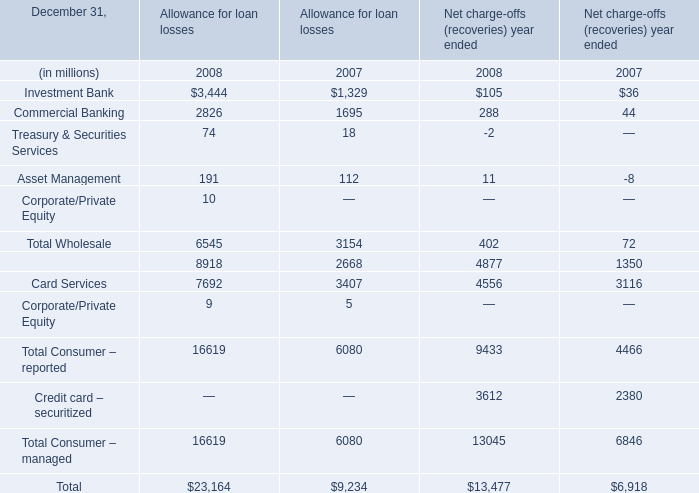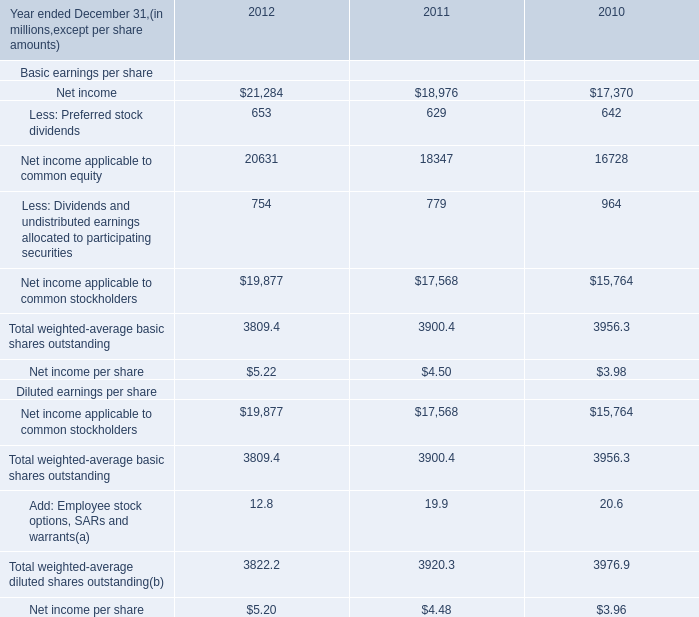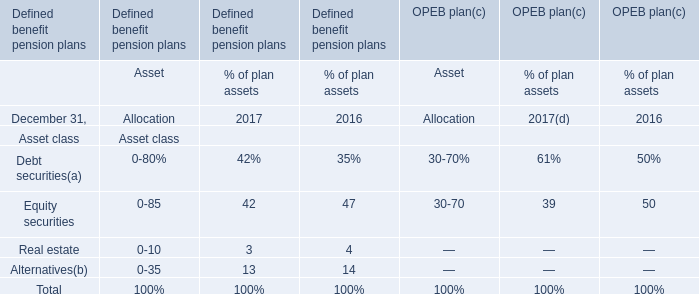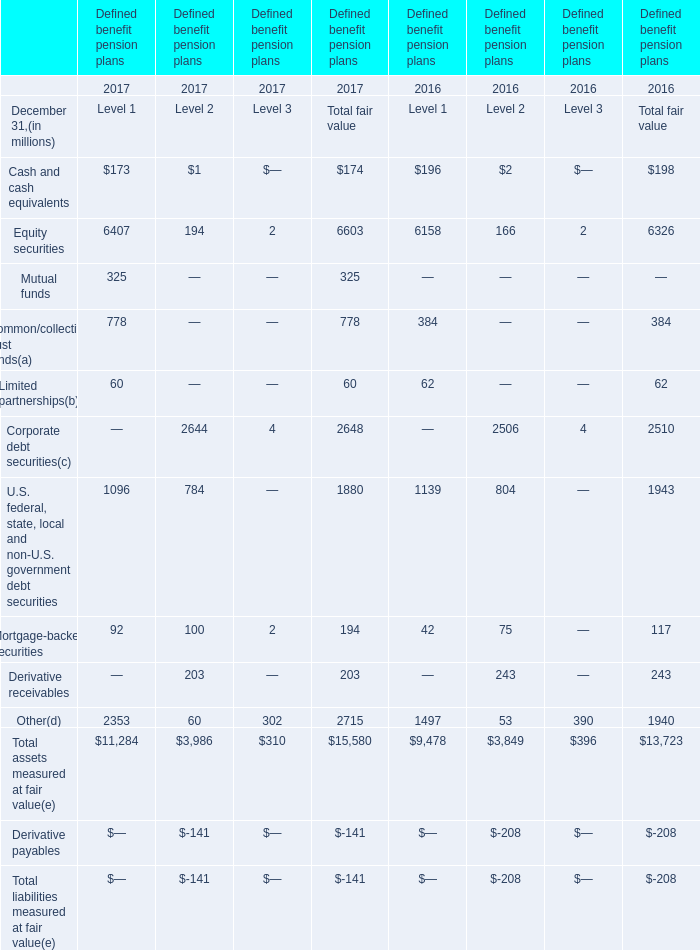What is the total amount of Retail Financial Services of Allowance for loan losses 2008, Other of Defined benefit pension plans 2016 Level 1, and Total Consumer – managed of Allowance for loan losses 2008 ? 
Computations: ((8918.0 + 1497.0) + 16619.0)
Answer: 27034.0. 